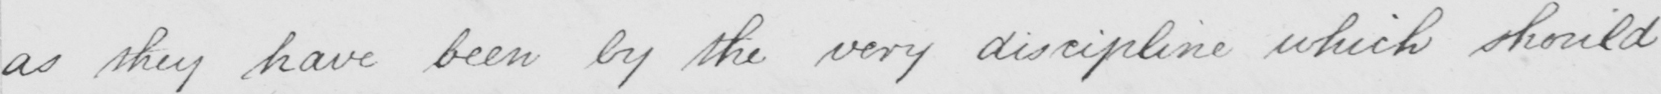What is written in this line of handwriting? as they have been by the very discipline which should 